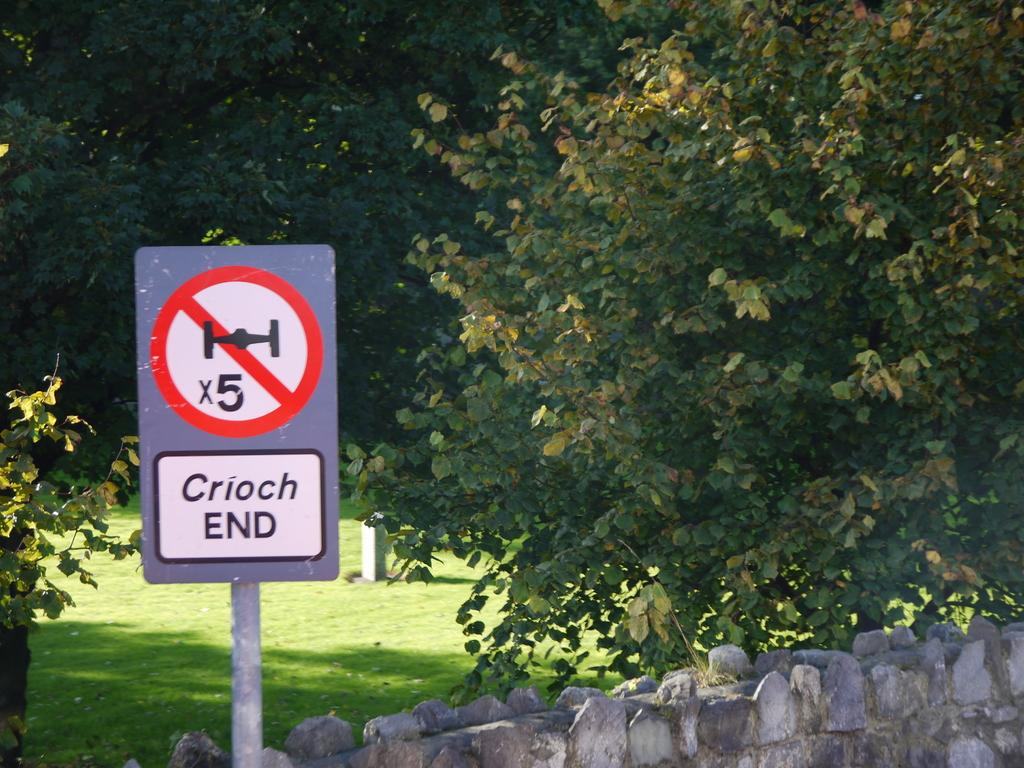Provide a one-sentence caption for the provided image. A sign next to a stone wall indicates Crioch End. 